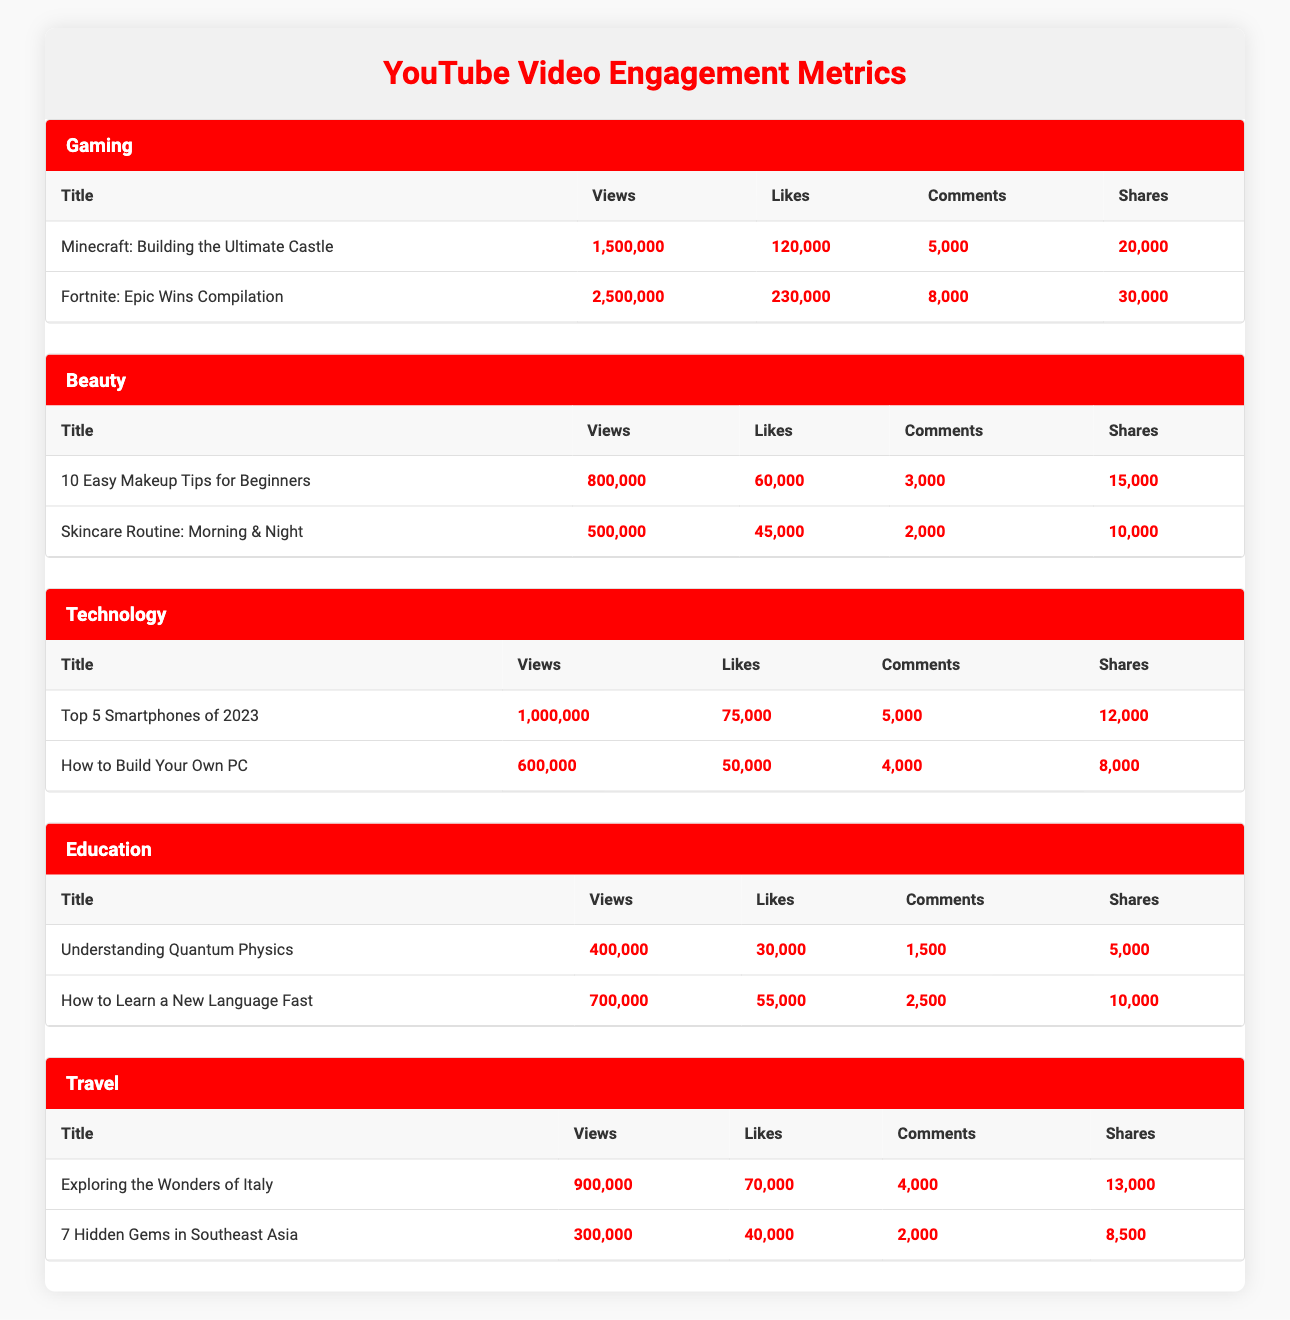What's the video with the highest number of views in the Gaming category? The Gaming category has two videos listed. “Fortnite: Epic Wins Compilation” has the highest views at 2,500,000, while “Minecraft: Building the Ultimate Castle” has 1,500,000 views. Thus, the video with the highest number of views is “Fortnite: Epic Wins Compilation.”
Answer: Fortnite: Epic Wins Compilation What is the total number of likes across all videos in the Beauty category? The two videos in the Beauty category are “10 Easy Makeup Tips for Beginners” with 60,000 likes and “Skincare Routine: Morning & Night” with 45,000 likes. Summing these gives 60,000 + 45,000 = 105,000 likes in total across all videos in this category.
Answer: 105000 Is there a video in the Education category that has more likes than any video in the Gaming category? The Gaming category has “Fortnite: Epic Wins Compilation” with 230,000 likes and “Minecraft: Building the Ultimate Castle” with 120,000 likes. In the Education category, the likes are 30,000 for “Understanding Quantum Physics” and 55,000 for “How to Learn a New Language Fast.” Since the highest likes in Education (55,000) is less than both videos in Gaming, the answer is no.
Answer: No What are the total views for all the videos in the Technology category? The Technology category includes “Top 5 Smartphones of 2023” with 1,000,000 views and “How to Build Your Own PC” with 600,000 views. The total views can be calculated by adding these two: 1,000,000 + 600,000 = 1,600,000.
Answer: 1600000 Which content category has the least number of total shares? To find the category with the least shares, we shall calculate the total shares for each category. The shares for Gaming total 50,000 (20,000 + 30,000), Beauty total 25,000 (15,000 + 10,000), Technology 20,000 (12,000 + 8,000), Education 15,000 (5,000 + 10,000), and Travel total 21,500 (13,000 + 8,500). The lowest total is in the Education category with 15,000 shares.
Answer: Education 